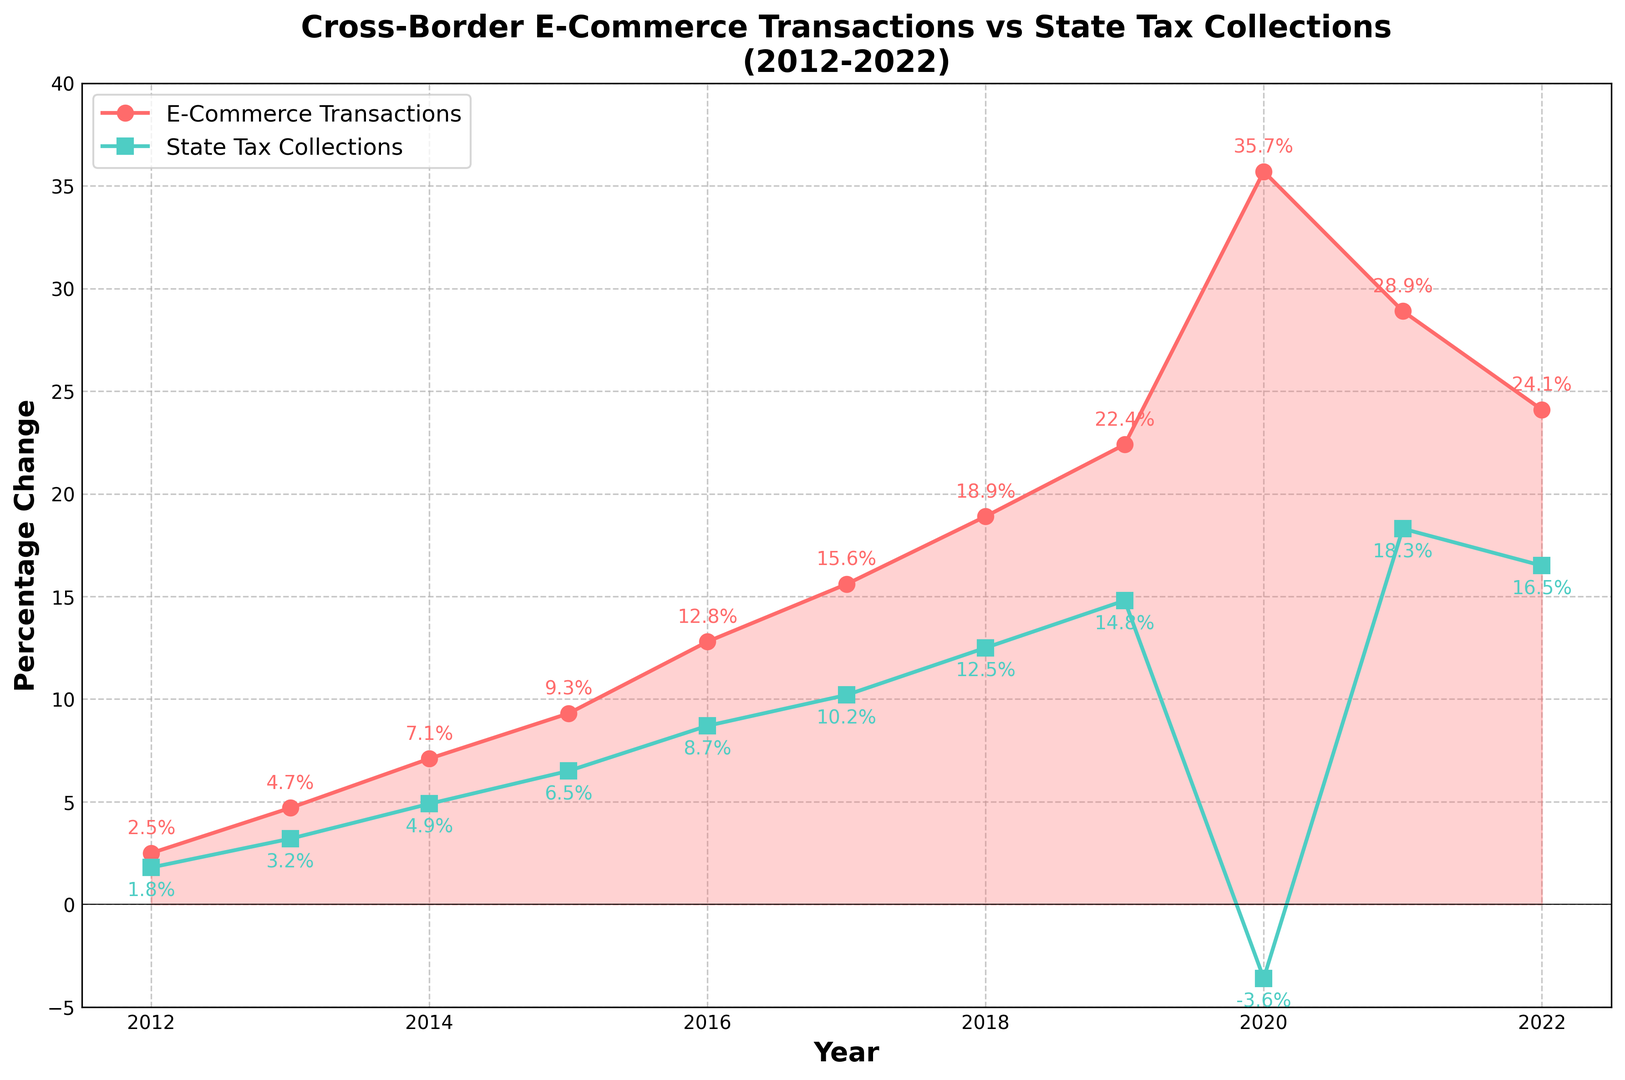What was the percentage change in cross-border e-commerce transactions in 2020? The figure shows the percentage changes over the years. For 2020, look at the data point that corresponds to 2020 on the e-commerce transactions line (red line).
Answer: 35.7% In which year did state tax collections see a negative change? The state tax collections line (green line) dips below the zero line in one year. This occurs in 2020.
Answer: 2020 During which year was the difference between the percentage change in cross-border e-commerce transactions and state tax collections the largest? Calculate the differences for each year. The largest difference appears in 2020: abs(35.7 - (-3.6)) = 39.3%.
Answer: 2020 Compare the percentage change in cross-border e-commerce transactions and state tax collections in 2018. Which one was higher and by how much? In 2018, compare the values: 18.9% for e-commerce and 12.5% for state tax collections. The difference is 18.9% - 12.5% = 6.4%.
Answer: E-commerce was higher by 6.4% Identify the year in which the percentage change in state tax collections was the highest. Look for the highest data point on the green line representing state tax collections. This occurs in 2021.
Answer: 2021 What is the average yearly percentage change in cross-border e-commerce transactions from 2012 to 2022? Sum all the yearly percentage changes and divide by the number of years: (2.5 + 4.7 + 7.1 + 9.3 + 12.8 + 15.6 + 18.9 + 22.4 + 35.7 + 28.9 + 24.1) / 11 ≈ 16.46.
Answer: 16.46% Which year observed the smallest positive change in state tax collections? Identify the smallest positive value on the green line. In 2012, the percentage change is 1.8%.
Answer: 2012 How did state tax collections change 2020 relative to their trend from 2012 to 2019? From 2012 to 2019, state tax collections were steadily increasing. In 2020, they drastically dropped to -3.6%, breaking the upward trend.
Answer: Drastically dropped Compare the overall trends of cross-border e-commerce transactions and state tax collections from 2012 to 2022. Both series generally increase over the period, but e-commerce growth is more pronounced, especially sharply rising in 2020, while tax collections steadily increase except in 2020.
Answer: Similar upwards, tax collections steady, e-commerce sharper rise By which year did the percentage change in e-commerce transactions surpass 10%? Identify when the red line crosses above 10%. This occurs in 2016.
Answer: 2016 